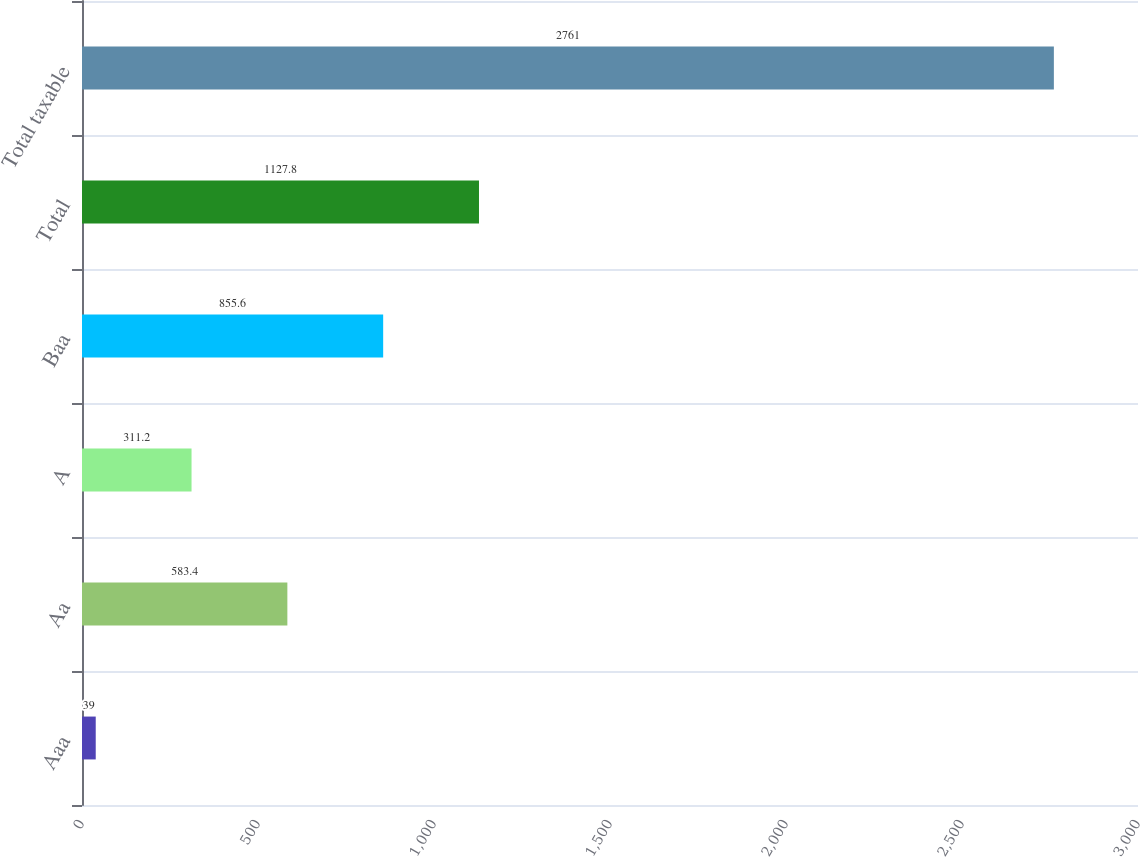Convert chart to OTSL. <chart><loc_0><loc_0><loc_500><loc_500><bar_chart><fcel>Aaa<fcel>Aa<fcel>A<fcel>Baa<fcel>Total<fcel>Total taxable<nl><fcel>39<fcel>583.4<fcel>311.2<fcel>855.6<fcel>1127.8<fcel>2761<nl></chart> 